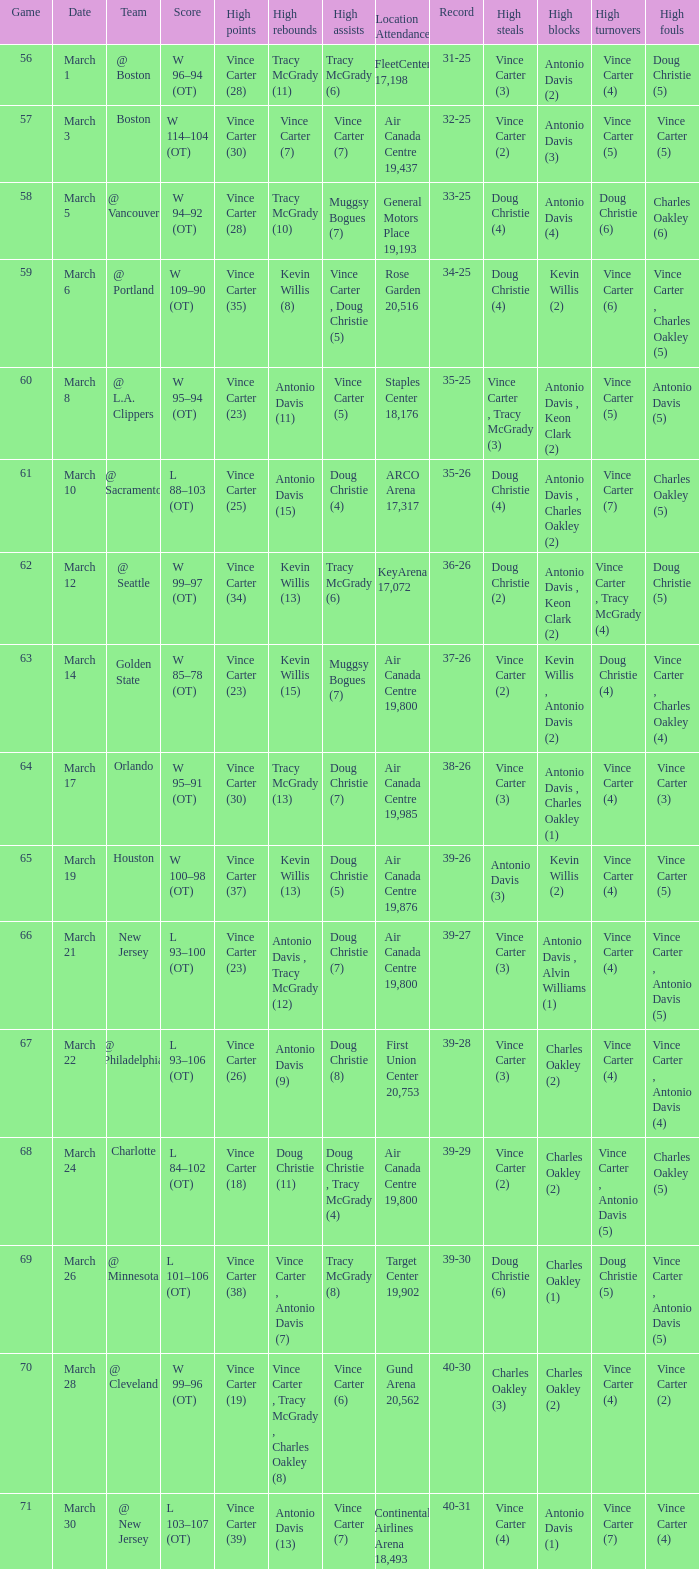Can you give me this table as a dict? {'header': ['Game', 'Date', 'Team', 'Score', 'High points', 'High rebounds', 'High assists', 'Location Attendance', 'Record', 'High steals', 'High blocks', 'High turnovers', 'High fouls'], 'rows': [['56', 'March 1', '@ Boston', 'W 96–94 (OT)', 'Vince Carter (28)', 'Tracy McGrady (11)', 'Tracy McGrady (6)', 'FleetCenter 17,198', '31-25', 'Vince Carter (3)', 'Antonio Davis (2)', 'Vince Carter (4)', 'Doug Christie (5)'], ['57', 'March 3', 'Boston', 'W 114–104 (OT)', 'Vince Carter (30)', 'Vince Carter (7)', 'Vince Carter (7)', 'Air Canada Centre 19,437', '32-25', 'Vince Carter (2)', 'Antonio Davis (3)', 'Vince Carter (5)', 'Vince Carter (5)'], ['58', 'March 5', '@ Vancouver', 'W 94–92 (OT)', 'Vince Carter (28)', 'Tracy McGrady (10)', 'Muggsy Bogues (7)', 'General Motors Place 19,193', '33-25', 'Doug Christie (4)', 'Antonio Davis (4)', 'Doug Christie (6)', 'Charles Oakley (6)'], ['59', 'March 6', '@ Portland', 'W 109–90 (OT)', 'Vince Carter (35)', 'Kevin Willis (8)', 'Vince Carter , Doug Christie (5)', 'Rose Garden 20,516', '34-25', 'Doug Christie (4)', 'Kevin Willis (2)', 'Vince Carter (6)', 'Vince Carter , Charles Oakley (5)'], ['60', 'March 8', '@ L.A. Clippers', 'W 95–94 (OT)', 'Vince Carter (23)', 'Antonio Davis (11)', 'Vince Carter (5)', 'Staples Center 18,176', '35-25', 'Vince Carter , Tracy McGrady (3)', 'Antonio Davis , Keon Clark (2)', 'Vince Carter (5)', 'Antonio Davis (5)'], ['61', 'March 10', '@ Sacramento', 'L 88–103 (OT)', 'Vince Carter (25)', 'Antonio Davis (15)', 'Doug Christie (4)', 'ARCO Arena 17,317', '35-26', 'Doug Christie (4)', 'Antonio Davis , Charles Oakley (2)', 'Vince Carter (7)', 'Charles Oakley (5)'], ['62', 'March 12', '@ Seattle', 'W 99–97 (OT)', 'Vince Carter (34)', 'Kevin Willis (13)', 'Tracy McGrady (6)', 'KeyArena 17,072', '36-26', 'Doug Christie (2)', 'Antonio Davis , Keon Clark (2)', 'Vince Carter , Tracy McGrady (4)', 'Doug Christie (5)'], ['63', 'March 14', 'Golden State', 'W 85–78 (OT)', 'Vince Carter (23)', 'Kevin Willis (15)', 'Muggsy Bogues (7)', 'Air Canada Centre 19,800', '37-26', 'Vince Carter (2)', 'Kevin Willis , Antonio Davis (2)', 'Doug Christie (4)', 'Vince Carter , Charles Oakley (4)'], ['64', 'March 17', 'Orlando', 'W 95–91 (OT)', 'Vince Carter (30)', 'Tracy McGrady (13)', 'Doug Christie (7)', 'Air Canada Centre 19,985', '38-26', 'Vince Carter (3)', 'Antonio Davis , Charles Oakley (1)', 'Vince Carter (4)', 'Vince Carter (3)'], ['65', 'March 19', 'Houston', 'W 100–98 (OT)', 'Vince Carter (37)', 'Kevin Willis (13)', 'Doug Christie (5)', 'Air Canada Centre 19,876', '39-26', 'Antonio Davis (3)', 'Kevin Willis (2)', 'Vince Carter (4)', 'Vince Carter (5)'], ['66', 'March 21', 'New Jersey', 'L 93–100 (OT)', 'Vince Carter (23)', 'Antonio Davis , Tracy McGrady (12)', 'Doug Christie (7)', 'Air Canada Centre 19,800', '39-27', 'Vince Carter (3)', 'Antonio Davis , Alvin Williams (1)', 'Vince Carter (4)', 'Vince Carter , Antonio Davis (5)'], ['67', 'March 22', '@ Philadelphia', 'L 93–106 (OT)', 'Vince Carter (26)', 'Antonio Davis (9)', 'Doug Christie (8)', 'First Union Center 20,753', '39-28', 'Vince Carter (3)', 'Charles Oakley (2)', 'Vince Carter (4)', 'Vince Carter , Antonio Davis (4)'], ['68', 'March 24', 'Charlotte', 'L 84–102 (OT)', 'Vince Carter (18)', 'Doug Christie (11)', 'Doug Christie , Tracy McGrady (4)', 'Air Canada Centre 19,800', '39-29', 'Vince Carter (2)', 'Charles Oakley (2)', 'Vince Carter , Antonio Davis (5)', 'Charles Oakley (5)'], ['69', 'March 26', '@ Minnesota', 'L 101–106 (OT)', 'Vince Carter (38)', 'Vince Carter , Antonio Davis (7)', 'Tracy McGrady (8)', 'Target Center 19,902', '39-30', 'Doug Christie (6)', 'Charles Oakley (1)', 'Doug Christie (5)', 'Vince Carter , Antonio Davis (5)'], ['70', 'March 28', '@ Cleveland', 'W 99–96 (OT)', 'Vince Carter (19)', 'Vince Carter , Tracy McGrady , Charles Oakley (8)', 'Vince Carter (6)', 'Gund Arena 20,562', '40-30', 'Charles Oakley (3)', 'Charles Oakley (2)', 'Vince Carter (4)', 'Vince Carter (2)'], ['71', 'March 30', '@ New Jersey', 'L 103–107 (OT)', 'Vince Carter (39)', 'Antonio Davis (13)', 'Vince Carter (7)', 'Continental Airlines Arena 18,493', '40-31', 'Vince Carter (4)', 'Antonio Davis (1)', 'Vince Carter (7)', 'Vince Carter (4)']]} How many people had the high assists @ minnesota? 1.0. 